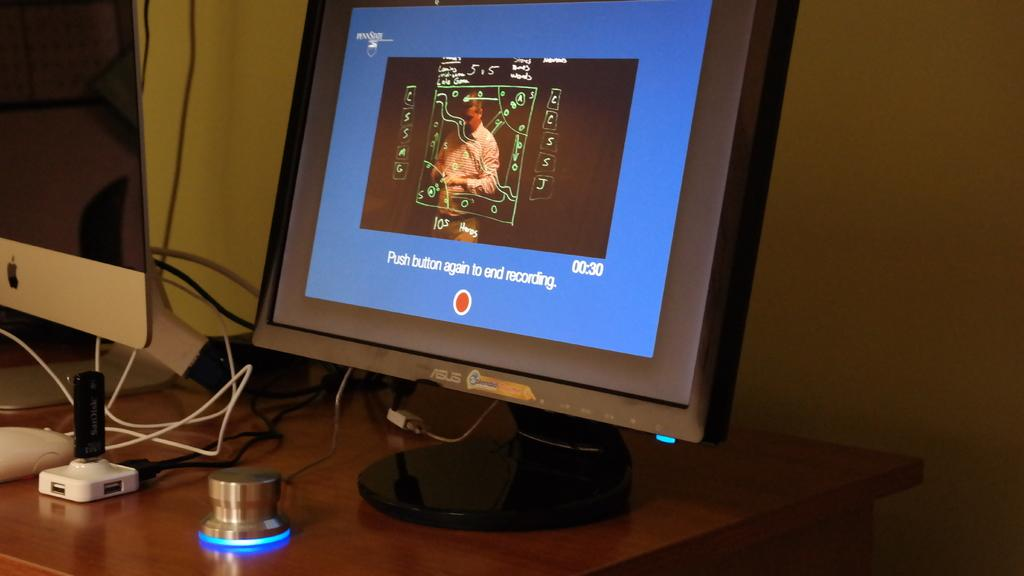<image>
Provide a brief description of the given image. Instructions of "Push button again to end recording" is displayed on the screen of the monitor. 